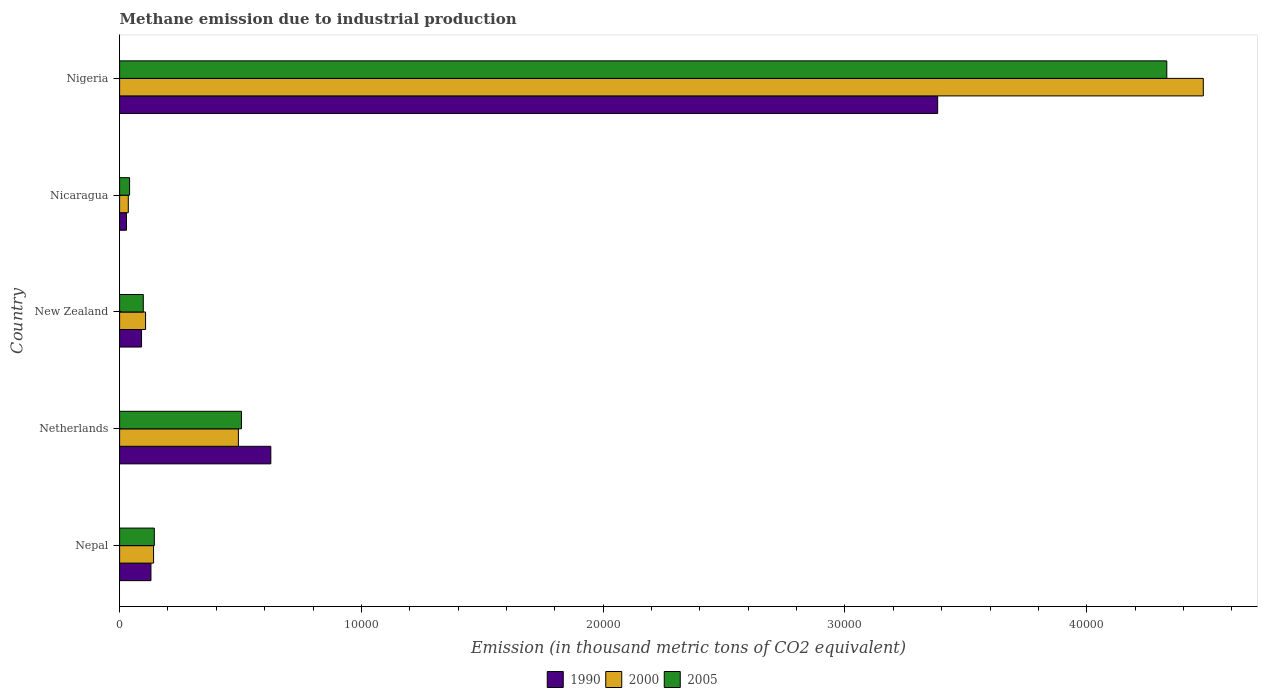How many groups of bars are there?
Make the answer very short. 5. Are the number of bars per tick equal to the number of legend labels?
Your response must be concise. Yes. Are the number of bars on each tick of the Y-axis equal?
Your answer should be very brief. Yes. How many bars are there on the 4th tick from the top?
Offer a very short reply. 3. What is the label of the 3rd group of bars from the top?
Provide a short and direct response. New Zealand. What is the amount of methane emitted in 2000 in New Zealand?
Your answer should be very brief. 1074. Across all countries, what is the maximum amount of methane emitted in 1990?
Give a very brief answer. 3.38e+04. Across all countries, what is the minimum amount of methane emitted in 2000?
Provide a succinct answer. 359.5. In which country was the amount of methane emitted in 2000 maximum?
Offer a very short reply. Nigeria. In which country was the amount of methane emitted in 2000 minimum?
Your response must be concise. Nicaragua. What is the total amount of methane emitted in 2005 in the graph?
Offer a terse response. 5.12e+04. What is the difference between the amount of methane emitted in 2005 in New Zealand and that in Nigeria?
Ensure brevity in your answer.  -4.23e+04. What is the difference between the amount of methane emitted in 2000 in Nicaragua and the amount of methane emitted in 1990 in Nigeria?
Your answer should be compact. -3.35e+04. What is the average amount of methane emitted in 2000 per country?
Offer a very short reply. 1.05e+04. What is the difference between the amount of methane emitted in 1990 and amount of methane emitted in 2000 in New Zealand?
Your answer should be compact. -167.2. In how many countries, is the amount of methane emitted in 2005 greater than 2000 thousand metric tons?
Offer a terse response. 2. What is the ratio of the amount of methane emitted in 2000 in Nepal to that in Nicaragua?
Provide a succinct answer. 3.91. What is the difference between the highest and the second highest amount of methane emitted in 2000?
Offer a very short reply. 3.99e+04. What is the difference between the highest and the lowest amount of methane emitted in 1990?
Offer a very short reply. 3.35e+04. Are the values on the major ticks of X-axis written in scientific E-notation?
Make the answer very short. No. Does the graph contain any zero values?
Provide a short and direct response. No. Where does the legend appear in the graph?
Your response must be concise. Bottom center. How many legend labels are there?
Offer a terse response. 3. How are the legend labels stacked?
Your response must be concise. Horizontal. What is the title of the graph?
Offer a very short reply. Methane emission due to industrial production. Does "1984" appear as one of the legend labels in the graph?
Keep it short and to the point. No. What is the label or title of the X-axis?
Your response must be concise. Emission (in thousand metric tons of CO2 equivalent). What is the label or title of the Y-axis?
Give a very brief answer. Country. What is the Emission (in thousand metric tons of CO2 equivalent) in 1990 in Nepal?
Offer a terse response. 1296.6. What is the Emission (in thousand metric tons of CO2 equivalent) of 2000 in Nepal?
Provide a succinct answer. 1405.1. What is the Emission (in thousand metric tons of CO2 equivalent) of 2005 in Nepal?
Make the answer very short. 1435.8. What is the Emission (in thousand metric tons of CO2 equivalent) in 1990 in Netherlands?
Provide a succinct answer. 6254.4. What is the Emission (in thousand metric tons of CO2 equivalent) of 2000 in Netherlands?
Offer a terse response. 4913.4. What is the Emission (in thousand metric tons of CO2 equivalent) of 2005 in Netherlands?
Your answer should be very brief. 5039.5. What is the Emission (in thousand metric tons of CO2 equivalent) of 1990 in New Zealand?
Ensure brevity in your answer.  906.8. What is the Emission (in thousand metric tons of CO2 equivalent) of 2000 in New Zealand?
Give a very brief answer. 1074. What is the Emission (in thousand metric tons of CO2 equivalent) of 2005 in New Zealand?
Keep it short and to the point. 979.4. What is the Emission (in thousand metric tons of CO2 equivalent) of 1990 in Nicaragua?
Provide a short and direct response. 284.1. What is the Emission (in thousand metric tons of CO2 equivalent) of 2000 in Nicaragua?
Your response must be concise. 359.5. What is the Emission (in thousand metric tons of CO2 equivalent) of 2005 in Nicaragua?
Ensure brevity in your answer.  412.7. What is the Emission (in thousand metric tons of CO2 equivalent) of 1990 in Nigeria?
Ensure brevity in your answer.  3.38e+04. What is the Emission (in thousand metric tons of CO2 equivalent) in 2000 in Nigeria?
Offer a very short reply. 4.48e+04. What is the Emission (in thousand metric tons of CO2 equivalent) of 2005 in Nigeria?
Keep it short and to the point. 4.33e+04. Across all countries, what is the maximum Emission (in thousand metric tons of CO2 equivalent) in 1990?
Keep it short and to the point. 3.38e+04. Across all countries, what is the maximum Emission (in thousand metric tons of CO2 equivalent) in 2000?
Give a very brief answer. 4.48e+04. Across all countries, what is the maximum Emission (in thousand metric tons of CO2 equivalent) of 2005?
Provide a succinct answer. 4.33e+04. Across all countries, what is the minimum Emission (in thousand metric tons of CO2 equivalent) in 1990?
Offer a very short reply. 284.1. Across all countries, what is the minimum Emission (in thousand metric tons of CO2 equivalent) in 2000?
Provide a succinct answer. 359.5. Across all countries, what is the minimum Emission (in thousand metric tons of CO2 equivalent) of 2005?
Give a very brief answer. 412.7. What is the total Emission (in thousand metric tons of CO2 equivalent) of 1990 in the graph?
Make the answer very short. 4.26e+04. What is the total Emission (in thousand metric tons of CO2 equivalent) in 2000 in the graph?
Give a very brief answer. 5.26e+04. What is the total Emission (in thousand metric tons of CO2 equivalent) of 2005 in the graph?
Offer a very short reply. 5.12e+04. What is the difference between the Emission (in thousand metric tons of CO2 equivalent) in 1990 in Nepal and that in Netherlands?
Your answer should be very brief. -4957.8. What is the difference between the Emission (in thousand metric tons of CO2 equivalent) in 2000 in Nepal and that in Netherlands?
Provide a succinct answer. -3508.3. What is the difference between the Emission (in thousand metric tons of CO2 equivalent) in 2005 in Nepal and that in Netherlands?
Your answer should be very brief. -3603.7. What is the difference between the Emission (in thousand metric tons of CO2 equivalent) in 1990 in Nepal and that in New Zealand?
Your response must be concise. 389.8. What is the difference between the Emission (in thousand metric tons of CO2 equivalent) of 2000 in Nepal and that in New Zealand?
Your response must be concise. 331.1. What is the difference between the Emission (in thousand metric tons of CO2 equivalent) of 2005 in Nepal and that in New Zealand?
Offer a very short reply. 456.4. What is the difference between the Emission (in thousand metric tons of CO2 equivalent) in 1990 in Nepal and that in Nicaragua?
Provide a succinct answer. 1012.5. What is the difference between the Emission (in thousand metric tons of CO2 equivalent) in 2000 in Nepal and that in Nicaragua?
Provide a succinct answer. 1045.6. What is the difference between the Emission (in thousand metric tons of CO2 equivalent) of 2005 in Nepal and that in Nicaragua?
Provide a succinct answer. 1023.1. What is the difference between the Emission (in thousand metric tons of CO2 equivalent) of 1990 in Nepal and that in Nigeria?
Your answer should be compact. -3.25e+04. What is the difference between the Emission (in thousand metric tons of CO2 equivalent) of 2000 in Nepal and that in Nigeria?
Ensure brevity in your answer.  -4.34e+04. What is the difference between the Emission (in thousand metric tons of CO2 equivalent) of 2005 in Nepal and that in Nigeria?
Your answer should be very brief. -4.19e+04. What is the difference between the Emission (in thousand metric tons of CO2 equivalent) of 1990 in Netherlands and that in New Zealand?
Make the answer very short. 5347.6. What is the difference between the Emission (in thousand metric tons of CO2 equivalent) in 2000 in Netherlands and that in New Zealand?
Your answer should be compact. 3839.4. What is the difference between the Emission (in thousand metric tons of CO2 equivalent) of 2005 in Netherlands and that in New Zealand?
Give a very brief answer. 4060.1. What is the difference between the Emission (in thousand metric tons of CO2 equivalent) in 1990 in Netherlands and that in Nicaragua?
Your response must be concise. 5970.3. What is the difference between the Emission (in thousand metric tons of CO2 equivalent) in 2000 in Netherlands and that in Nicaragua?
Provide a short and direct response. 4553.9. What is the difference between the Emission (in thousand metric tons of CO2 equivalent) in 2005 in Netherlands and that in Nicaragua?
Offer a terse response. 4626.8. What is the difference between the Emission (in thousand metric tons of CO2 equivalent) in 1990 in Netherlands and that in Nigeria?
Make the answer very short. -2.76e+04. What is the difference between the Emission (in thousand metric tons of CO2 equivalent) of 2000 in Netherlands and that in Nigeria?
Provide a short and direct response. -3.99e+04. What is the difference between the Emission (in thousand metric tons of CO2 equivalent) in 2005 in Netherlands and that in Nigeria?
Your answer should be very brief. -3.83e+04. What is the difference between the Emission (in thousand metric tons of CO2 equivalent) in 1990 in New Zealand and that in Nicaragua?
Provide a succinct answer. 622.7. What is the difference between the Emission (in thousand metric tons of CO2 equivalent) in 2000 in New Zealand and that in Nicaragua?
Offer a very short reply. 714.5. What is the difference between the Emission (in thousand metric tons of CO2 equivalent) in 2005 in New Zealand and that in Nicaragua?
Make the answer very short. 566.7. What is the difference between the Emission (in thousand metric tons of CO2 equivalent) in 1990 in New Zealand and that in Nigeria?
Offer a terse response. -3.29e+04. What is the difference between the Emission (in thousand metric tons of CO2 equivalent) in 2000 in New Zealand and that in Nigeria?
Provide a short and direct response. -4.37e+04. What is the difference between the Emission (in thousand metric tons of CO2 equivalent) of 2005 in New Zealand and that in Nigeria?
Make the answer very short. -4.23e+04. What is the difference between the Emission (in thousand metric tons of CO2 equivalent) in 1990 in Nicaragua and that in Nigeria?
Make the answer very short. -3.35e+04. What is the difference between the Emission (in thousand metric tons of CO2 equivalent) in 2000 in Nicaragua and that in Nigeria?
Your response must be concise. -4.45e+04. What is the difference between the Emission (in thousand metric tons of CO2 equivalent) of 2005 in Nicaragua and that in Nigeria?
Ensure brevity in your answer.  -4.29e+04. What is the difference between the Emission (in thousand metric tons of CO2 equivalent) in 1990 in Nepal and the Emission (in thousand metric tons of CO2 equivalent) in 2000 in Netherlands?
Offer a very short reply. -3616.8. What is the difference between the Emission (in thousand metric tons of CO2 equivalent) of 1990 in Nepal and the Emission (in thousand metric tons of CO2 equivalent) of 2005 in Netherlands?
Make the answer very short. -3742.9. What is the difference between the Emission (in thousand metric tons of CO2 equivalent) of 2000 in Nepal and the Emission (in thousand metric tons of CO2 equivalent) of 2005 in Netherlands?
Give a very brief answer. -3634.4. What is the difference between the Emission (in thousand metric tons of CO2 equivalent) in 1990 in Nepal and the Emission (in thousand metric tons of CO2 equivalent) in 2000 in New Zealand?
Offer a very short reply. 222.6. What is the difference between the Emission (in thousand metric tons of CO2 equivalent) in 1990 in Nepal and the Emission (in thousand metric tons of CO2 equivalent) in 2005 in New Zealand?
Give a very brief answer. 317.2. What is the difference between the Emission (in thousand metric tons of CO2 equivalent) in 2000 in Nepal and the Emission (in thousand metric tons of CO2 equivalent) in 2005 in New Zealand?
Ensure brevity in your answer.  425.7. What is the difference between the Emission (in thousand metric tons of CO2 equivalent) of 1990 in Nepal and the Emission (in thousand metric tons of CO2 equivalent) of 2000 in Nicaragua?
Offer a terse response. 937.1. What is the difference between the Emission (in thousand metric tons of CO2 equivalent) in 1990 in Nepal and the Emission (in thousand metric tons of CO2 equivalent) in 2005 in Nicaragua?
Offer a terse response. 883.9. What is the difference between the Emission (in thousand metric tons of CO2 equivalent) of 2000 in Nepal and the Emission (in thousand metric tons of CO2 equivalent) of 2005 in Nicaragua?
Make the answer very short. 992.4. What is the difference between the Emission (in thousand metric tons of CO2 equivalent) in 1990 in Nepal and the Emission (in thousand metric tons of CO2 equivalent) in 2000 in Nigeria?
Ensure brevity in your answer.  -4.35e+04. What is the difference between the Emission (in thousand metric tons of CO2 equivalent) in 1990 in Nepal and the Emission (in thousand metric tons of CO2 equivalent) in 2005 in Nigeria?
Offer a terse response. -4.20e+04. What is the difference between the Emission (in thousand metric tons of CO2 equivalent) of 2000 in Nepal and the Emission (in thousand metric tons of CO2 equivalent) of 2005 in Nigeria?
Your answer should be compact. -4.19e+04. What is the difference between the Emission (in thousand metric tons of CO2 equivalent) in 1990 in Netherlands and the Emission (in thousand metric tons of CO2 equivalent) in 2000 in New Zealand?
Ensure brevity in your answer.  5180.4. What is the difference between the Emission (in thousand metric tons of CO2 equivalent) in 1990 in Netherlands and the Emission (in thousand metric tons of CO2 equivalent) in 2005 in New Zealand?
Offer a very short reply. 5275. What is the difference between the Emission (in thousand metric tons of CO2 equivalent) of 2000 in Netherlands and the Emission (in thousand metric tons of CO2 equivalent) of 2005 in New Zealand?
Make the answer very short. 3934. What is the difference between the Emission (in thousand metric tons of CO2 equivalent) in 1990 in Netherlands and the Emission (in thousand metric tons of CO2 equivalent) in 2000 in Nicaragua?
Your answer should be compact. 5894.9. What is the difference between the Emission (in thousand metric tons of CO2 equivalent) of 1990 in Netherlands and the Emission (in thousand metric tons of CO2 equivalent) of 2005 in Nicaragua?
Offer a terse response. 5841.7. What is the difference between the Emission (in thousand metric tons of CO2 equivalent) of 2000 in Netherlands and the Emission (in thousand metric tons of CO2 equivalent) of 2005 in Nicaragua?
Your response must be concise. 4500.7. What is the difference between the Emission (in thousand metric tons of CO2 equivalent) in 1990 in Netherlands and the Emission (in thousand metric tons of CO2 equivalent) in 2000 in Nigeria?
Make the answer very short. -3.86e+04. What is the difference between the Emission (in thousand metric tons of CO2 equivalent) of 1990 in Netherlands and the Emission (in thousand metric tons of CO2 equivalent) of 2005 in Nigeria?
Make the answer very short. -3.71e+04. What is the difference between the Emission (in thousand metric tons of CO2 equivalent) in 2000 in Netherlands and the Emission (in thousand metric tons of CO2 equivalent) in 2005 in Nigeria?
Provide a succinct answer. -3.84e+04. What is the difference between the Emission (in thousand metric tons of CO2 equivalent) in 1990 in New Zealand and the Emission (in thousand metric tons of CO2 equivalent) in 2000 in Nicaragua?
Give a very brief answer. 547.3. What is the difference between the Emission (in thousand metric tons of CO2 equivalent) of 1990 in New Zealand and the Emission (in thousand metric tons of CO2 equivalent) of 2005 in Nicaragua?
Provide a succinct answer. 494.1. What is the difference between the Emission (in thousand metric tons of CO2 equivalent) in 2000 in New Zealand and the Emission (in thousand metric tons of CO2 equivalent) in 2005 in Nicaragua?
Keep it short and to the point. 661.3. What is the difference between the Emission (in thousand metric tons of CO2 equivalent) in 1990 in New Zealand and the Emission (in thousand metric tons of CO2 equivalent) in 2000 in Nigeria?
Your answer should be compact. -4.39e+04. What is the difference between the Emission (in thousand metric tons of CO2 equivalent) in 1990 in New Zealand and the Emission (in thousand metric tons of CO2 equivalent) in 2005 in Nigeria?
Offer a terse response. -4.24e+04. What is the difference between the Emission (in thousand metric tons of CO2 equivalent) in 2000 in New Zealand and the Emission (in thousand metric tons of CO2 equivalent) in 2005 in Nigeria?
Ensure brevity in your answer.  -4.22e+04. What is the difference between the Emission (in thousand metric tons of CO2 equivalent) in 1990 in Nicaragua and the Emission (in thousand metric tons of CO2 equivalent) in 2000 in Nigeria?
Your answer should be compact. -4.45e+04. What is the difference between the Emission (in thousand metric tons of CO2 equivalent) of 1990 in Nicaragua and the Emission (in thousand metric tons of CO2 equivalent) of 2005 in Nigeria?
Provide a short and direct response. -4.30e+04. What is the difference between the Emission (in thousand metric tons of CO2 equivalent) in 2000 in Nicaragua and the Emission (in thousand metric tons of CO2 equivalent) in 2005 in Nigeria?
Offer a terse response. -4.30e+04. What is the average Emission (in thousand metric tons of CO2 equivalent) in 1990 per country?
Ensure brevity in your answer.  8515.08. What is the average Emission (in thousand metric tons of CO2 equivalent) of 2000 per country?
Make the answer very short. 1.05e+04. What is the average Emission (in thousand metric tons of CO2 equivalent) in 2005 per country?
Ensure brevity in your answer.  1.02e+04. What is the difference between the Emission (in thousand metric tons of CO2 equivalent) of 1990 and Emission (in thousand metric tons of CO2 equivalent) of 2000 in Nepal?
Make the answer very short. -108.5. What is the difference between the Emission (in thousand metric tons of CO2 equivalent) in 1990 and Emission (in thousand metric tons of CO2 equivalent) in 2005 in Nepal?
Offer a very short reply. -139.2. What is the difference between the Emission (in thousand metric tons of CO2 equivalent) of 2000 and Emission (in thousand metric tons of CO2 equivalent) of 2005 in Nepal?
Give a very brief answer. -30.7. What is the difference between the Emission (in thousand metric tons of CO2 equivalent) in 1990 and Emission (in thousand metric tons of CO2 equivalent) in 2000 in Netherlands?
Keep it short and to the point. 1341. What is the difference between the Emission (in thousand metric tons of CO2 equivalent) in 1990 and Emission (in thousand metric tons of CO2 equivalent) in 2005 in Netherlands?
Keep it short and to the point. 1214.9. What is the difference between the Emission (in thousand metric tons of CO2 equivalent) in 2000 and Emission (in thousand metric tons of CO2 equivalent) in 2005 in Netherlands?
Your answer should be very brief. -126.1. What is the difference between the Emission (in thousand metric tons of CO2 equivalent) of 1990 and Emission (in thousand metric tons of CO2 equivalent) of 2000 in New Zealand?
Your response must be concise. -167.2. What is the difference between the Emission (in thousand metric tons of CO2 equivalent) in 1990 and Emission (in thousand metric tons of CO2 equivalent) in 2005 in New Zealand?
Provide a short and direct response. -72.6. What is the difference between the Emission (in thousand metric tons of CO2 equivalent) in 2000 and Emission (in thousand metric tons of CO2 equivalent) in 2005 in New Zealand?
Your response must be concise. 94.6. What is the difference between the Emission (in thousand metric tons of CO2 equivalent) of 1990 and Emission (in thousand metric tons of CO2 equivalent) of 2000 in Nicaragua?
Your response must be concise. -75.4. What is the difference between the Emission (in thousand metric tons of CO2 equivalent) of 1990 and Emission (in thousand metric tons of CO2 equivalent) of 2005 in Nicaragua?
Your response must be concise. -128.6. What is the difference between the Emission (in thousand metric tons of CO2 equivalent) of 2000 and Emission (in thousand metric tons of CO2 equivalent) of 2005 in Nicaragua?
Offer a very short reply. -53.2. What is the difference between the Emission (in thousand metric tons of CO2 equivalent) of 1990 and Emission (in thousand metric tons of CO2 equivalent) of 2000 in Nigeria?
Offer a very short reply. -1.10e+04. What is the difference between the Emission (in thousand metric tons of CO2 equivalent) of 1990 and Emission (in thousand metric tons of CO2 equivalent) of 2005 in Nigeria?
Provide a short and direct response. -9476.4. What is the difference between the Emission (in thousand metric tons of CO2 equivalent) of 2000 and Emission (in thousand metric tons of CO2 equivalent) of 2005 in Nigeria?
Provide a short and direct response. 1509.9. What is the ratio of the Emission (in thousand metric tons of CO2 equivalent) of 1990 in Nepal to that in Netherlands?
Your answer should be compact. 0.21. What is the ratio of the Emission (in thousand metric tons of CO2 equivalent) of 2000 in Nepal to that in Netherlands?
Your answer should be compact. 0.29. What is the ratio of the Emission (in thousand metric tons of CO2 equivalent) of 2005 in Nepal to that in Netherlands?
Ensure brevity in your answer.  0.28. What is the ratio of the Emission (in thousand metric tons of CO2 equivalent) of 1990 in Nepal to that in New Zealand?
Give a very brief answer. 1.43. What is the ratio of the Emission (in thousand metric tons of CO2 equivalent) of 2000 in Nepal to that in New Zealand?
Your response must be concise. 1.31. What is the ratio of the Emission (in thousand metric tons of CO2 equivalent) in 2005 in Nepal to that in New Zealand?
Make the answer very short. 1.47. What is the ratio of the Emission (in thousand metric tons of CO2 equivalent) of 1990 in Nepal to that in Nicaragua?
Offer a terse response. 4.56. What is the ratio of the Emission (in thousand metric tons of CO2 equivalent) of 2000 in Nepal to that in Nicaragua?
Provide a short and direct response. 3.91. What is the ratio of the Emission (in thousand metric tons of CO2 equivalent) in 2005 in Nepal to that in Nicaragua?
Your response must be concise. 3.48. What is the ratio of the Emission (in thousand metric tons of CO2 equivalent) in 1990 in Nepal to that in Nigeria?
Give a very brief answer. 0.04. What is the ratio of the Emission (in thousand metric tons of CO2 equivalent) of 2000 in Nepal to that in Nigeria?
Ensure brevity in your answer.  0.03. What is the ratio of the Emission (in thousand metric tons of CO2 equivalent) of 2005 in Nepal to that in Nigeria?
Your answer should be very brief. 0.03. What is the ratio of the Emission (in thousand metric tons of CO2 equivalent) of 1990 in Netherlands to that in New Zealand?
Give a very brief answer. 6.9. What is the ratio of the Emission (in thousand metric tons of CO2 equivalent) of 2000 in Netherlands to that in New Zealand?
Ensure brevity in your answer.  4.57. What is the ratio of the Emission (in thousand metric tons of CO2 equivalent) in 2005 in Netherlands to that in New Zealand?
Ensure brevity in your answer.  5.15. What is the ratio of the Emission (in thousand metric tons of CO2 equivalent) of 1990 in Netherlands to that in Nicaragua?
Your answer should be very brief. 22.01. What is the ratio of the Emission (in thousand metric tons of CO2 equivalent) of 2000 in Netherlands to that in Nicaragua?
Keep it short and to the point. 13.67. What is the ratio of the Emission (in thousand metric tons of CO2 equivalent) in 2005 in Netherlands to that in Nicaragua?
Provide a short and direct response. 12.21. What is the ratio of the Emission (in thousand metric tons of CO2 equivalent) in 1990 in Netherlands to that in Nigeria?
Your response must be concise. 0.18. What is the ratio of the Emission (in thousand metric tons of CO2 equivalent) of 2000 in Netherlands to that in Nigeria?
Give a very brief answer. 0.11. What is the ratio of the Emission (in thousand metric tons of CO2 equivalent) of 2005 in Netherlands to that in Nigeria?
Ensure brevity in your answer.  0.12. What is the ratio of the Emission (in thousand metric tons of CO2 equivalent) of 1990 in New Zealand to that in Nicaragua?
Offer a terse response. 3.19. What is the ratio of the Emission (in thousand metric tons of CO2 equivalent) of 2000 in New Zealand to that in Nicaragua?
Give a very brief answer. 2.99. What is the ratio of the Emission (in thousand metric tons of CO2 equivalent) of 2005 in New Zealand to that in Nicaragua?
Your response must be concise. 2.37. What is the ratio of the Emission (in thousand metric tons of CO2 equivalent) of 1990 in New Zealand to that in Nigeria?
Your answer should be very brief. 0.03. What is the ratio of the Emission (in thousand metric tons of CO2 equivalent) of 2000 in New Zealand to that in Nigeria?
Keep it short and to the point. 0.02. What is the ratio of the Emission (in thousand metric tons of CO2 equivalent) in 2005 in New Zealand to that in Nigeria?
Make the answer very short. 0.02. What is the ratio of the Emission (in thousand metric tons of CO2 equivalent) of 1990 in Nicaragua to that in Nigeria?
Provide a succinct answer. 0.01. What is the ratio of the Emission (in thousand metric tons of CO2 equivalent) of 2000 in Nicaragua to that in Nigeria?
Your response must be concise. 0.01. What is the ratio of the Emission (in thousand metric tons of CO2 equivalent) of 2005 in Nicaragua to that in Nigeria?
Keep it short and to the point. 0.01. What is the difference between the highest and the second highest Emission (in thousand metric tons of CO2 equivalent) of 1990?
Your answer should be very brief. 2.76e+04. What is the difference between the highest and the second highest Emission (in thousand metric tons of CO2 equivalent) of 2000?
Ensure brevity in your answer.  3.99e+04. What is the difference between the highest and the second highest Emission (in thousand metric tons of CO2 equivalent) of 2005?
Keep it short and to the point. 3.83e+04. What is the difference between the highest and the lowest Emission (in thousand metric tons of CO2 equivalent) in 1990?
Make the answer very short. 3.35e+04. What is the difference between the highest and the lowest Emission (in thousand metric tons of CO2 equivalent) of 2000?
Offer a terse response. 4.45e+04. What is the difference between the highest and the lowest Emission (in thousand metric tons of CO2 equivalent) of 2005?
Offer a very short reply. 4.29e+04. 